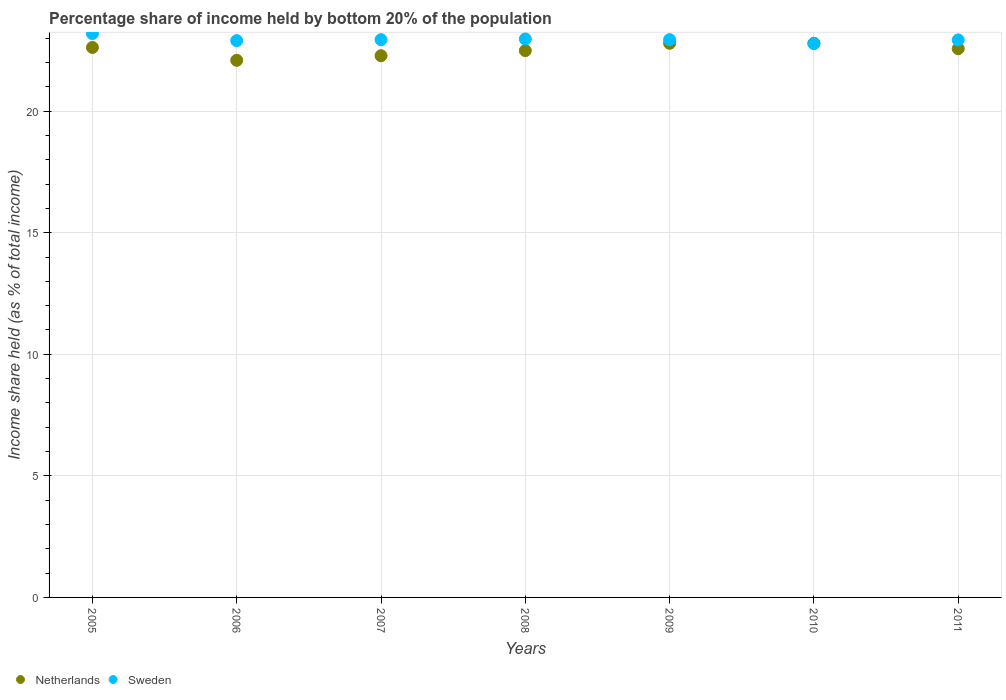How many different coloured dotlines are there?
Provide a short and direct response. 2. Is the number of dotlines equal to the number of legend labels?
Ensure brevity in your answer.  Yes. What is the share of income held by bottom 20% of the population in Netherlands in 2006?
Keep it short and to the point. 22.09. Across all years, what is the maximum share of income held by bottom 20% of the population in Netherlands?
Your answer should be very brief. 22.79. Across all years, what is the minimum share of income held by bottom 20% of the population in Netherlands?
Ensure brevity in your answer.  22.09. In which year was the share of income held by bottom 20% of the population in Netherlands minimum?
Keep it short and to the point. 2006. What is the total share of income held by bottom 20% of the population in Sweden in the graph?
Ensure brevity in your answer.  160.65. What is the difference between the share of income held by bottom 20% of the population in Netherlands in 2007 and that in 2010?
Your answer should be very brief. -0.51. What is the difference between the share of income held by bottom 20% of the population in Sweden in 2006 and the share of income held by bottom 20% of the population in Netherlands in 2011?
Your response must be concise. 0.33. What is the average share of income held by bottom 20% of the population in Sweden per year?
Your answer should be compact. 22.95. In the year 2006, what is the difference between the share of income held by bottom 20% of the population in Netherlands and share of income held by bottom 20% of the population in Sweden?
Offer a very short reply. -0.81. What is the ratio of the share of income held by bottom 20% of the population in Netherlands in 2005 to that in 2008?
Offer a very short reply. 1.01. Is the share of income held by bottom 20% of the population in Netherlands in 2005 less than that in 2006?
Your response must be concise. No. What is the difference between the highest and the second highest share of income held by bottom 20% of the population in Netherlands?
Ensure brevity in your answer.  0. What is the difference between the highest and the lowest share of income held by bottom 20% of the population in Sweden?
Make the answer very short. 0.41. In how many years, is the share of income held by bottom 20% of the population in Netherlands greater than the average share of income held by bottom 20% of the population in Netherlands taken over all years?
Provide a succinct answer. 4. Is the share of income held by bottom 20% of the population in Netherlands strictly greater than the share of income held by bottom 20% of the population in Sweden over the years?
Give a very brief answer. No. Is the share of income held by bottom 20% of the population in Sweden strictly less than the share of income held by bottom 20% of the population in Netherlands over the years?
Provide a succinct answer. No. How many dotlines are there?
Provide a succinct answer. 2. How many years are there in the graph?
Your answer should be compact. 7. Does the graph contain any zero values?
Ensure brevity in your answer.  No. How many legend labels are there?
Provide a succinct answer. 2. What is the title of the graph?
Give a very brief answer. Percentage share of income held by bottom 20% of the population. What is the label or title of the X-axis?
Give a very brief answer. Years. What is the label or title of the Y-axis?
Provide a succinct answer. Income share held (as % of total income). What is the Income share held (as % of total income) in Netherlands in 2005?
Offer a very short reply. 22.62. What is the Income share held (as % of total income) of Sweden in 2005?
Make the answer very short. 23.19. What is the Income share held (as % of total income) of Netherlands in 2006?
Your answer should be compact. 22.09. What is the Income share held (as % of total income) in Sweden in 2006?
Keep it short and to the point. 22.9. What is the Income share held (as % of total income) in Netherlands in 2007?
Ensure brevity in your answer.  22.28. What is the Income share held (as % of total income) in Sweden in 2007?
Make the answer very short. 22.94. What is the Income share held (as % of total income) of Netherlands in 2008?
Offer a terse response. 22.49. What is the Income share held (as % of total income) in Sweden in 2008?
Your response must be concise. 22.97. What is the Income share held (as % of total income) of Netherlands in 2009?
Your answer should be compact. 22.79. What is the Income share held (as % of total income) of Sweden in 2009?
Offer a very short reply. 22.94. What is the Income share held (as % of total income) in Netherlands in 2010?
Offer a very short reply. 22.79. What is the Income share held (as % of total income) in Sweden in 2010?
Provide a succinct answer. 22.78. What is the Income share held (as % of total income) in Netherlands in 2011?
Offer a terse response. 22.57. What is the Income share held (as % of total income) in Sweden in 2011?
Ensure brevity in your answer.  22.93. Across all years, what is the maximum Income share held (as % of total income) of Netherlands?
Ensure brevity in your answer.  22.79. Across all years, what is the maximum Income share held (as % of total income) in Sweden?
Give a very brief answer. 23.19. Across all years, what is the minimum Income share held (as % of total income) in Netherlands?
Keep it short and to the point. 22.09. Across all years, what is the minimum Income share held (as % of total income) in Sweden?
Offer a terse response. 22.78. What is the total Income share held (as % of total income) in Netherlands in the graph?
Your answer should be very brief. 157.63. What is the total Income share held (as % of total income) in Sweden in the graph?
Provide a succinct answer. 160.65. What is the difference between the Income share held (as % of total income) of Netherlands in 2005 and that in 2006?
Keep it short and to the point. 0.53. What is the difference between the Income share held (as % of total income) in Sweden in 2005 and that in 2006?
Your answer should be very brief. 0.29. What is the difference between the Income share held (as % of total income) in Netherlands in 2005 and that in 2007?
Provide a short and direct response. 0.34. What is the difference between the Income share held (as % of total income) in Netherlands in 2005 and that in 2008?
Ensure brevity in your answer.  0.13. What is the difference between the Income share held (as % of total income) in Sweden in 2005 and that in 2008?
Offer a very short reply. 0.22. What is the difference between the Income share held (as % of total income) of Netherlands in 2005 and that in 2009?
Offer a terse response. -0.17. What is the difference between the Income share held (as % of total income) in Sweden in 2005 and that in 2009?
Your response must be concise. 0.25. What is the difference between the Income share held (as % of total income) of Netherlands in 2005 and that in 2010?
Provide a succinct answer. -0.17. What is the difference between the Income share held (as % of total income) of Sweden in 2005 and that in 2010?
Your answer should be compact. 0.41. What is the difference between the Income share held (as % of total income) of Netherlands in 2005 and that in 2011?
Provide a short and direct response. 0.05. What is the difference between the Income share held (as % of total income) in Sweden in 2005 and that in 2011?
Ensure brevity in your answer.  0.26. What is the difference between the Income share held (as % of total income) in Netherlands in 2006 and that in 2007?
Provide a short and direct response. -0.19. What is the difference between the Income share held (as % of total income) of Sweden in 2006 and that in 2007?
Provide a short and direct response. -0.04. What is the difference between the Income share held (as % of total income) in Sweden in 2006 and that in 2008?
Your answer should be very brief. -0.07. What is the difference between the Income share held (as % of total income) in Sweden in 2006 and that in 2009?
Give a very brief answer. -0.04. What is the difference between the Income share held (as % of total income) of Sweden in 2006 and that in 2010?
Keep it short and to the point. 0.12. What is the difference between the Income share held (as % of total income) in Netherlands in 2006 and that in 2011?
Give a very brief answer. -0.48. What is the difference between the Income share held (as % of total income) of Sweden in 2006 and that in 2011?
Offer a very short reply. -0.03. What is the difference between the Income share held (as % of total income) of Netherlands in 2007 and that in 2008?
Give a very brief answer. -0.21. What is the difference between the Income share held (as % of total income) of Sweden in 2007 and that in 2008?
Ensure brevity in your answer.  -0.03. What is the difference between the Income share held (as % of total income) in Netherlands in 2007 and that in 2009?
Keep it short and to the point. -0.51. What is the difference between the Income share held (as % of total income) of Sweden in 2007 and that in 2009?
Ensure brevity in your answer.  0. What is the difference between the Income share held (as % of total income) of Netherlands in 2007 and that in 2010?
Offer a terse response. -0.51. What is the difference between the Income share held (as % of total income) in Sweden in 2007 and that in 2010?
Provide a succinct answer. 0.16. What is the difference between the Income share held (as % of total income) of Netherlands in 2007 and that in 2011?
Ensure brevity in your answer.  -0.29. What is the difference between the Income share held (as % of total income) of Sweden in 2007 and that in 2011?
Give a very brief answer. 0.01. What is the difference between the Income share held (as % of total income) in Netherlands in 2008 and that in 2009?
Offer a very short reply. -0.3. What is the difference between the Income share held (as % of total income) in Sweden in 2008 and that in 2010?
Provide a short and direct response. 0.19. What is the difference between the Income share held (as % of total income) in Netherlands in 2008 and that in 2011?
Your answer should be compact. -0.08. What is the difference between the Income share held (as % of total income) of Netherlands in 2009 and that in 2010?
Ensure brevity in your answer.  0. What is the difference between the Income share held (as % of total income) of Sweden in 2009 and that in 2010?
Your response must be concise. 0.16. What is the difference between the Income share held (as % of total income) in Netherlands in 2009 and that in 2011?
Make the answer very short. 0.22. What is the difference between the Income share held (as % of total income) in Sweden in 2009 and that in 2011?
Ensure brevity in your answer.  0.01. What is the difference between the Income share held (as % of total income) in Netherlands in 2010 and that in 2011?
Your answer should be compact. 0.22. What is the difference between the Income share held (as % of total income) of Sweden in 2010 and that in 2011?
Ensure brevity in your answer.  -0.15. What is the difference between the Income share held (as % of total income) of Netherlands in 2005 and the Income share held (as % of total income) of Sweden in 2006?
Your answer should be very brief. -0.28. What is the difference between the Income share held (as % of total income) in Netherlands in 2005 and the Income share held (as % of total income) in Sweden in 2007?
Ensure brevity in your answer.  -0.32. What is the difference between the Income share held (as % of total income) of Netherlands in 2005 and the Income share held (as % of total income) of Sweden in 2008?
Your response must be concise. -0.35. What is the difference between the Income share held (as % of total income) in Netherlands in 2005 and the Income share held (as % of total income) in Sweden in 2009?
Ensure brevity in your answer.  -0.32. What is the difference between the Income share held (as % of total income) of Netherlands in 2005 and the Income share held (as % of total income) of Sweden in 2010?
Ensure brevity in your answer.  -0.16. What is the difference between the Income share held (as % of total income) of Netherlands in 2005 and the Income share held (as % of total income) of Sweden in 2011?
Provide a succinct answer. -0.31. What is the difference between the Income share held (as % of total income) of Netherlands in 2006 and the Income share held (as % of total income) of Sweden in 2007?
Keep it short and to the point. -0.85. What is the difference between the Income share held (as % of total income) of Netherlands in 2006 and the Income share held (as % of total income) of Sweden in 2008?
Your answer should be compact. -0.88. What is the difference between the Income share held (as % of total income) in Netherlands in 2006 and the Income share held (as % of total income) in Sweden in 2009?
Your answer should be compact. -0.85. What is the difference between the Income share held (as % of total income) in Netherlands in 2006 and the Income share held (as % of total income) in Sweden in 2010?
Give a very brief answer. -0.69. What is the difference between the Income share held (as % of total income) in Netherlands in 2006 and the Income share held (as % of total income) in Sweden in 2011?
Ensure brevity in your answer.  -0.84. What is the difference between the Income share held (as % of total income) in Netherlands in 2007 and the Income share held (as % of total income) in Sweden in 2008?
Offer a terse response. -0.69. What is the difference between the Income share held (as % of total income) in Netherlands in 2007 and the Income share held (as % of total income) in Sweden in 2009?
Offer a very short reply. -0.66. What is the difference between the Income share held (as % of total income) of Netherlands in 2007 and the Income share held (as % of total income) of Sweden in 2011?
Offer a terse response. -0.65. What is the difference between the Income share held (as % of total income) in Netherlands in 2008 and the Income share held (as % of total income) in Sweden in 2009?
Your response must be concise. -0.45. What is the difference between the Income share held (as % of total income) in Netherlands in 2008 and the Income share held (as % of total income) in Sweden in 2010?
Your answer should be compact. -0.29. What is the difference between the Income share held (as % of total income) of Netherlands in 2008 and the Income share held (as % of total income) of Sweden in 2011?
Give a very brief answer. -0.44. What is the difference between the Income share held (as % of total income) of Netherlands in 2009 and the Income share held (as % of total income) of Sweden in 2010?
Offer a very short reply. 0.01. What is the difference between the Income share held (as % of total income) in Netherlands in 2009 and the Income share held (as % of total income) in Sweden in 2011?
Offer a very short reply. -0.14. What is the difference between the Income share held (as % of total income) in Netherlands in 2010 and the Income share held (as % of total income) in Sweden in 2011?
Give a very brief answer. -0.14. What is the average Income share held (as % of total income) in Netherlands per year?
Keep it short and to the point. 22.52. What is the average Income share held (as % of total income) in Sweden per year?
Offer a very short reply. 22.95. In the year 2005, what is the difference between the Income share held (as % of total income) in Netherlands and Income share held (as % of total income) in Sweden?
Keep it short and to the point. -0.57. In the year 2006, what is the difference between the Income share held (as % of total income) in Netherlands and Income share held (as % of total income) in Sweden?
Your response must be concise. -0.81. In the year 2007, what is the difference between the Income share held (as % of total income) in Netherlands and Income share held (as % of total income) in Sweden?
Your answer should be compact. -0.66. In the year 2008, what is the difference between the Income share held (as % of total income) in Netherlands and Income share held (as % of total income) in Sweden?
Keep it short and to the point. -0.48. In the year 2009, what is the difference between the Income share held (as % of total income) in Netherlands and Income share held (as % of total income) in Sweden?
Your response must be concise. -0.15. In the year 2011, what is the difference between the Income share held (as % of total income) of Netherlands and Income share held (as % of total income) of Sweden?
Your answer should be very brief. -0.36. What is the ratio of the Income share held (as % of total income) in Netherlands in 2005 to that in 2006?
Provide a succinct answer. 1.02. What is the ratio of the Income share held (as % of total income) of Sweden in 2005 to that in 2006?
Ensure brevity in your answer.  1.01. What is the ratio of the Income share held (as % of total income) of Netherlands in 2005 to that in 2007?
Provide a succinct answer. 1.02. What is the ratio of the Income share held (as % of total income) in Sweden in 2005 to that in 2007?
Make the answer very short. 1.01. What is the ratio of the Income share held (as % of total income) of Netherlands in 2005 to that in 2008?
Provide a short and direct response. 1.01. What is the ratio of the Income share held (as % of total income) of Sweden in 2005 to that in 2008?
Your answer should be very brief. 1.01. What is the ratio of the Income share held (as % of total income) in Sweden in 2005 to that in 2009?
Keep it short and to the point. 1.01. What is the ratio of the Income share held (as % of total income) in Sweden in 2005 to that in 2010?
Provide a succinct answer. 1.02. What is the ratio of the Income share held (as % of total income) in Sweden in 2005 to that in 2011?
Provide a succinct answer. 1.01. What is the ratio of the Income share held (as % of total income) in Sweden in 2006 to that in 2007?
Your answer should be very brief. 1. What is the ratio of the Income share held (as % of total income) in Netherlands in 2006 to that in 2008?
Provide a short and direct response. 0.98. What is the ratio of the Income share held (as % of total income) in Sweden in 2006 to that in 2008?
Offer a very short reply. 1. What is the ratio of the Income share held (as % of total income) of Netherlands in 2006 to that in 2009?
Provide a short and direct response. 0.97. What is the ratio of the Income share held (as % of total income) in Netherlands in 2006 to that in 2010?
Your answer should be compact. 0.97. What is the ratio of the Income share held (as % of total income) of Netherlands in 2006 to that in 2011?
Ensure brevity in your answer.  0.98. What is the ratio of the Income share held (as % of total income) in Netherlands in 2007 to that in 2009?
Provide a succinct answer. 0.98. What is the ratio of the Income share held (as % of total income) of Sweden in 2007 to that in 2009?
Give a very brief answer. 1. What is the ratio of the Income share held (as % of total income) in Netherlands in 2007 to that in 2010?
Provide a short and direct response. 0.98. What is the ratio of the Income share held (as % of total income) in Netherlands in 2007 to that in 2011?
Your response must be concise. 0.99. What is the ratio of the Income share held (as % of total income) in Sweden in 2008 to that in 2009?
Offer a terse response. 1. What is the ratio of the Income share held (as % of total income) in Sweden in 2008 to that in 2010?
Offer a terse response. 1.01. What is the ratio of the Income share held (as % of total income) of Netherlands in 2008 to that in 2011?
Offer a terse response. 1. What is the ratio of the Income share held (as % of total income) of Sweden in 2008 to that in 2011?
Give a very brief answer. 1. What is the ratio of the Income share held (as % of total income) of Netherlands in 2009 to that in 2011?
Your answer should be compact. 1.01. What is the ratio of the Income share held (as % of total income) of Sweden in 2009 to that in 2011?
Keep it short and to the point. 1. What is the ratio of the Income share held (as % of total income) in Netherlands in 2010 to that in 2011?
Keep it short and to the point. 1.01. What is the difference between the highest and the second highest Income share held (as % of total income) of Netherlands?
Make the answer very short. 0. What is the difference between the highest and the second highest Income share held (as % of total income) of Sweden?
Give a very brief answer. 0.22. What is the difference between the highest and the lowest Income share held (as % of total income) in Sweden?
Provide a succinct answer. 0.41. 